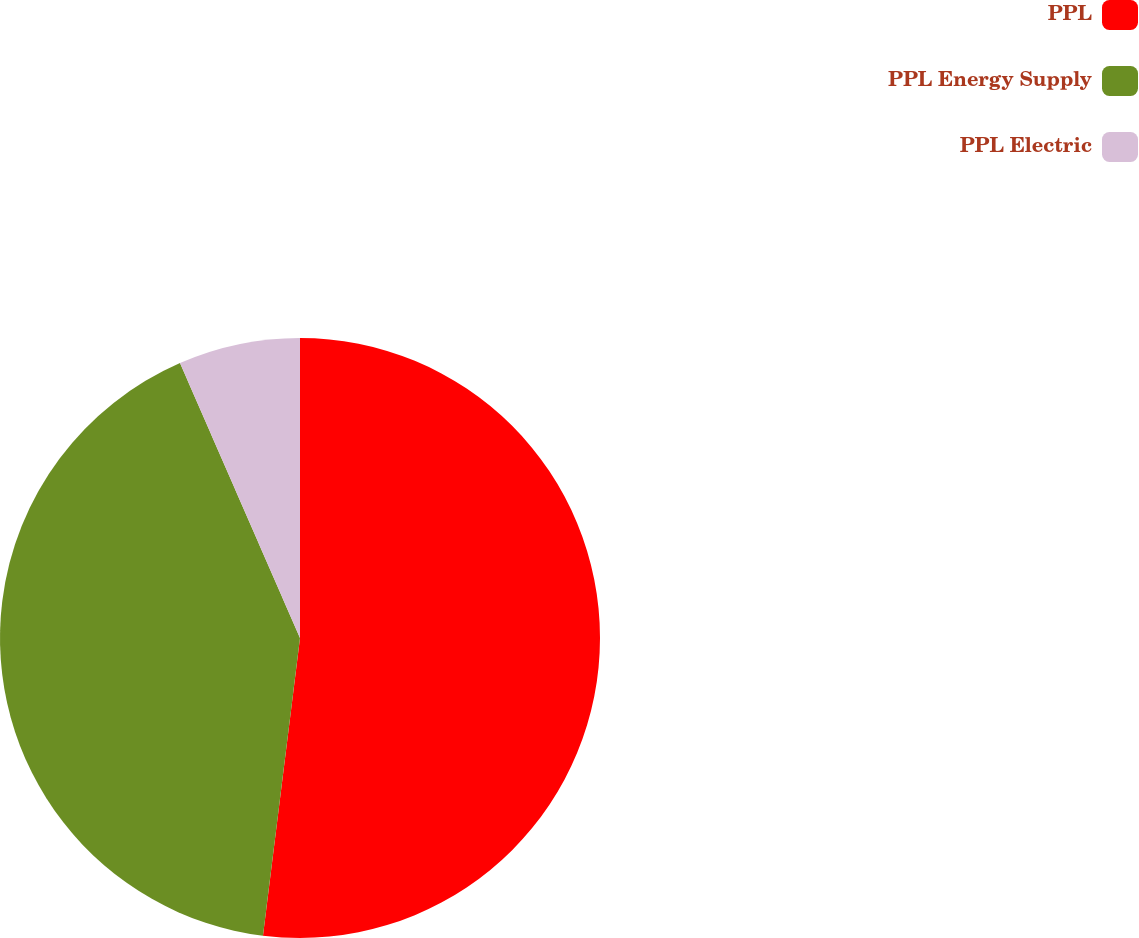Convert chart to OTSL. <chart><loc_0><loc_0><loc_500><loc_500><pie_chart><fcel>PPL<fcel>PPL Energy Supply<fcel>PPL Electric<nl><fcel>51.97%<fcel>41.48%<fcel>6.55%<nl></chart> 